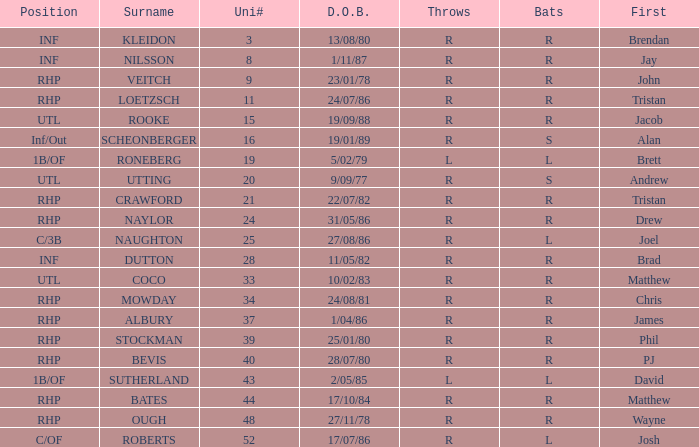Parse the table in full. {'header': ['Position', 'Surname', 'Uni#', 'D.O.B.', 'Throws', 'Bats', 'First'], 'rows': [['INF', 'KLEIDON', '3', '13/08/80', 'R', 'R', 'Brendan'], ['INF', 'NILSSON', '8', '1/11/87', 'R', 'R', 'Jay'], ['RHP', 'VEITCH', '9', '23/01/78', 'R', 'R', 'John'], ['RHP', 'LOETZSCH', '11', '24/07/86', 'R', 'R', 'Tristan'], ['UTL', 'ROOKE', '15', '19/09/88', 'R', 'R', 'Jacob'], ['Inf/Out', 'SCHEONBERGER', '16', '19/01/89', 'R', 'S', 'Alan'], ['1B/OF', 'RONEBERG', '19', '5/02/79', 'L', 'L', 'Brett'], ['UTL', 'UTTING', '20', '9/09/77', 'R', 'S', 'Andrew'], ['RHP', 'CRAWFORD', '21', '22/07/82', 'R', 'R', 'Tristan'], ['RHP', 'NAYLOR', '24', '31/05/86', 'R', 'R', 'Drew'], ['C/3B', 'NAUGHTON', '25', '27/08/86', 'R', 'L', 'Joel'], ['INF', 'DUTTON', '28', '11/05/82', 'R', 'R', 'Brad'], ['UTL', 'COCO', '33', '10/02/83', 'R', 'R', 'Matthew'], ['RHP', 'MOWDAY', '34', '24/08/81', 'R', 'R', 'Chris'], ['RHP', 'ALBURY', '37', '1/04/86', 'R', 'R', 'James'], ['RHP', 'STOCKMAN', '39', '25/01/80', 'R', 'R', 'Phil'], ['RHP', 'BEVIS', '40', '28/07/80', 'R', 'R', 'PJ'], ['1B/OF', 'SUTHERLAND', '43', '2/05/85', 'L', 'L', 'David'], ['RHP', 'BATES', '44', '17/10/84', 'R', 'R', 'Matthew'], ['RHP', 'OUGH', '48', '27/11/78', 'R', 'R', 'Wayne'], ['C/OF', 'ROBERTS', '52', '17/07/86', 'R', 'L', 'Josh']]} Which Uni # has a Surname of ough? 48.0. 